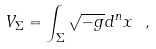Convert formula to latex. <formula><loc_0><loc_0><loc_500><loc_500>V _ { \Sigma } = \int _ { \Sigma } \sqrt { - g } d ^ { n } x \ ,</formula> 